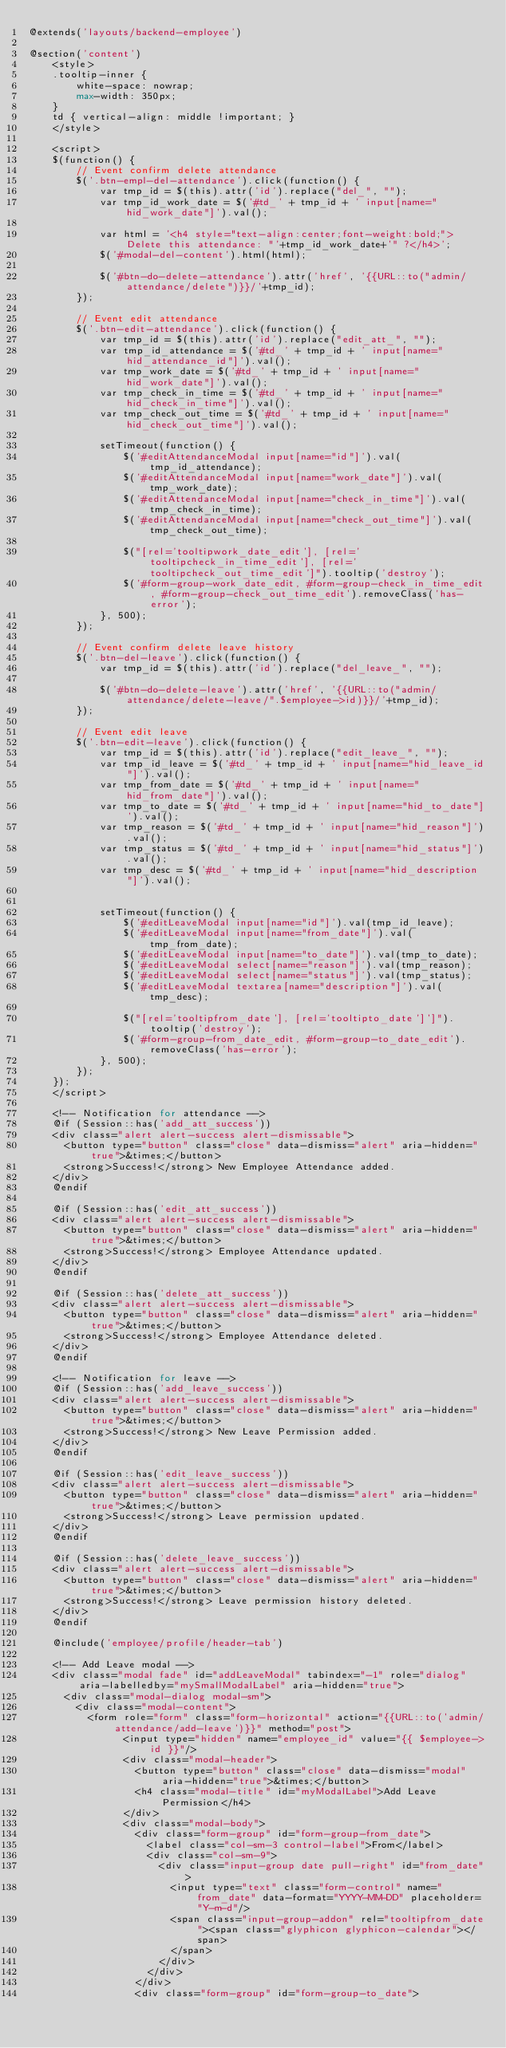<code> <loc_0><loc_0><loc_500><loc_500><_PHP_>@extends('layouts/backend-employee')

@section('content')
    <style>
    .tooltip-inner {
        white-space: nowrap;
        max-width: 350px;
    }
    td { vertical-align: middle !important; }
    </style>

    <script>
    $(function() {                     
        // Event confirm delete attendance            
        $('.btn-empl-del-attendance').click(function() {
            var tmp_id = $(this).attr('id').replace("del_", ""); 
            var tmp_id_work_date = $('#td_' + tmp_id + ' input[name="hid_work_date"]').val();

            var html = '<h4 style="text-align:center;font-weight:bold;">Delete this attendance: "'+tmp_id_work_date+'" ?</h4>';
            $('#modal-del-content').html(html);

            $('#btn-do-delete-attendance').attr('href', '{{URL::to("admin/attendance/delete")}}/'+tmp_id);
        });

        // Event edit attendance     
        $('.btn-edit-attendance').click(function() {
            var tmp_id = $(this).attr('id').replace("edit_att_", ""); 
            var tmp_id_attendance = $('#td_' + tmp_id + ' input[name="hid_attendance_id"]').val();
            var tmp_work_date = $('#td_' + tmp_id + ' input[name="hid_work_date"]').val();
            var tmp_check_in_time = $('#td_' + tmp_id + ' input[name="hid_check_in_time"]').val();
            var tmp_check_out_time = $('#td_' + tmp_id + ' input[name="hid_check_out_time"]').val();

            setTimeout(function() {
                $('#editAttendanceModal input[name="id"]').val(tmp_id_attendance);        
                $('#editAttendanceModal input[name="work_date"]').val(tmp_work_date);
                $('#editAttendanceModal input[name="check_in_time"]').val(tmp_check_in_time);
                $('#editAttendanceModal input[name="check_out_time"]').val(tmp_check_out_time);

                $("[rel='tooltipwork_date_edit'], [rel='tooltipcheck_in_time_edit'], [rel='tooltipcheck_out_time_edit']").tooltip('destroy');
                $('#form-group-work_date_edit, #form-group-check_in_time_edit, #form-group-check_out_time_edit').removeClass('has-error');
            }, 500);
        });

        // Event confirm delete leave history
        $('.btn-del-leave').click(function() {
            var tmp_id = $(this).attr('id').replace("del_leave_", ""); 

            $('#btn-do-delete-leave').attr('href', '{{URL::to("admin/attendance/delete-leave/".$employee->id)}}/'+tmp_id);
        });

        // Event edit leave     
        $('.btn-edit-leave').click(function() {
            var tmp_id = $(this).attr('id').replace("edit_leave_", ""); 
            var tmp_id_leave = $('#td_' + tmp_id + ' input[name="hid_leave_id"]').val();
            var tmp_from_date = $('#td_' + tmp_id + ' input[name="hid_from_date"]').val();
            var tmp_to_date = $('#td_' + tmp_id + ' input[name="hid_to_date"]').val();
            var tmp_reason = $('#td_' + tmp_id + ' input[name="hid_reason"]').val();
            var tmp_status = $('#td_' + tmp_id + ' input[name="hid_status"]').val();
            var tmp_desc = $('#td_' + tmp_id + ' input[name="hid_description"]').val();


            setTimeout(function() {
                $('#editLeaveModal input[name="id"]').val(tmp_id_leave);        
                $('#editLeaveModal input[name="from_date"]').val(tmp_from_date);
                $('#editLeaveModal input[name="to_date"]').val(tmp_to_date);
                $('#editLeaveModal select[name="reason"]').val(tmp_reason);
                $('#editLeaveModal select[name="status"]').val(tmp_status);
                $('#editLeaveModal textarea[name="description"]').val(tmp_desc);

                $("[rel='tooltipfrom_date'], [rel='tooltipto_date']']").tooltip('destroy');
                $('#form-group-from_date_edit, #form-group-to_date_edit').removeClass('has-error');
            }, 500);
        });
    });
    </script>
    
    <!-- Notification for attendance -->
    @if (Session::has('add_att_success'))
    <div class="alert alert-success alert-dismissable">
      <button type="button" class="close" data-dismiss="alert" aria-hidden="true">&times;</button>
      <strong>Success!</strong> New Employee Attendance added.
    </div>
    @endif
    
    @if (Session::has('edit_att_success'))
    <div class="alert alert-success alert-dismissable">
      <button type="button" class="close" data-dismiss="alert" aria-hidden="true">&times;</button>
      <strong>Success!</strong> Employee Attendance updated.
    </div>
    @endif
    
    @if (Session::has('delete_att_success'))
    <div class="alert alert-success alert-dismissable">
      <button type="button" class="close" data-dismiss="alert" aria-hidden="true">&times;</button>
      <strong>Success!</strong> Employee Attendance deleted.
    </div>
    @endif

    <!-- Notification for leave -->
    @if (Session::has('add_leave_success'))
    <div class="alert alert-success alert-dismissable">
      <button type="button" class="close" data-dismiss="alert" aria-hidden="true">&times;</button>
      <strong>Success!</strong> New Leave Permission added.
    </div>
    @endif
    
    @if (Session::has('edit_leave_success'))
    <div class="alert alert-success alert-dismissable">
      <button type="button" class="close" data-dismiss="alert" aria-hidden="true">&times;</button>
      <strong>Success!</strong> Leave permission updated.
    </div>
    @endif
    
    @if (Session::has('delete_leave_success'))
    <div class="alert alert-success alert-dismissable">
      <button type="button" class="close" data-dismiss="alert" aria-hidden="true">&times;</button>
      <strong>Success!</strong> Leave permission history deleted.
    </div>
    @endif
    
    @include('employee/profile/header-tab')
    
    <!-- Add Leave modal -->
    <div class="modal fade" id="addLeaveModal" tabindex="-1" role="dialog" aria-labelledby="mySmallModalLabel" aria-hidden="true">
      <div class="modal-dialog modal-sm">
        <div class="modal-content">
          <form role="form" class="form-horizontal" action="{{URL::to('admin/attendance/add-leave')}}" method="post">
                <input type="hidden" name="employee_id" value="{{ $employee->id }}"/>
                <div class="modal-header">
                  <button type="button" class="close" data-dismiss="modal" aria-hidden="true">&times;</button>
                  <h4 class="modal-title" id="myModalLabel">Add Leave Permission</h4>
                </div>
                <div class="modal-body">
                  <div class="form-group" id="form-group-from_date">
                    <label class="col-sm-3 control-label">From</label>
                    <div class="col-sm-9">
                      <div class="input-group date pull-right" id="from_date">
                        <input type="text" class="form-control" name="from_date" data-format="YYYY-MM-DD" placeholder="Y-m-d"/>
                        <span class="input-group-addon" rel="tooltipfrom_date"><span class="glyphicon glyphicon-calendar"></span>
                        </span>
                      </div>
                    </div>
                  </div>
                  <div class="form-group" id="form-group-to_date"></code> 